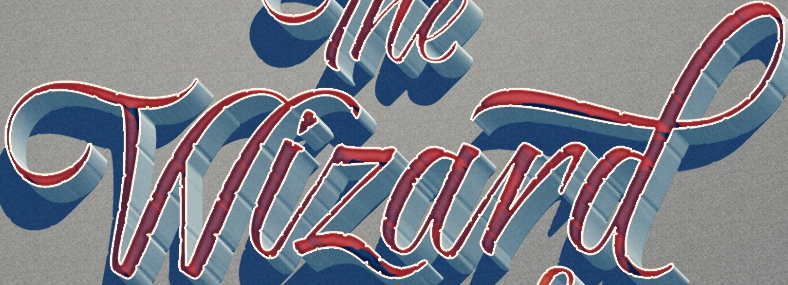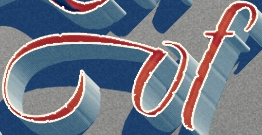Read the text from these images in sequence, separated by a semicolon. Wizard; of 